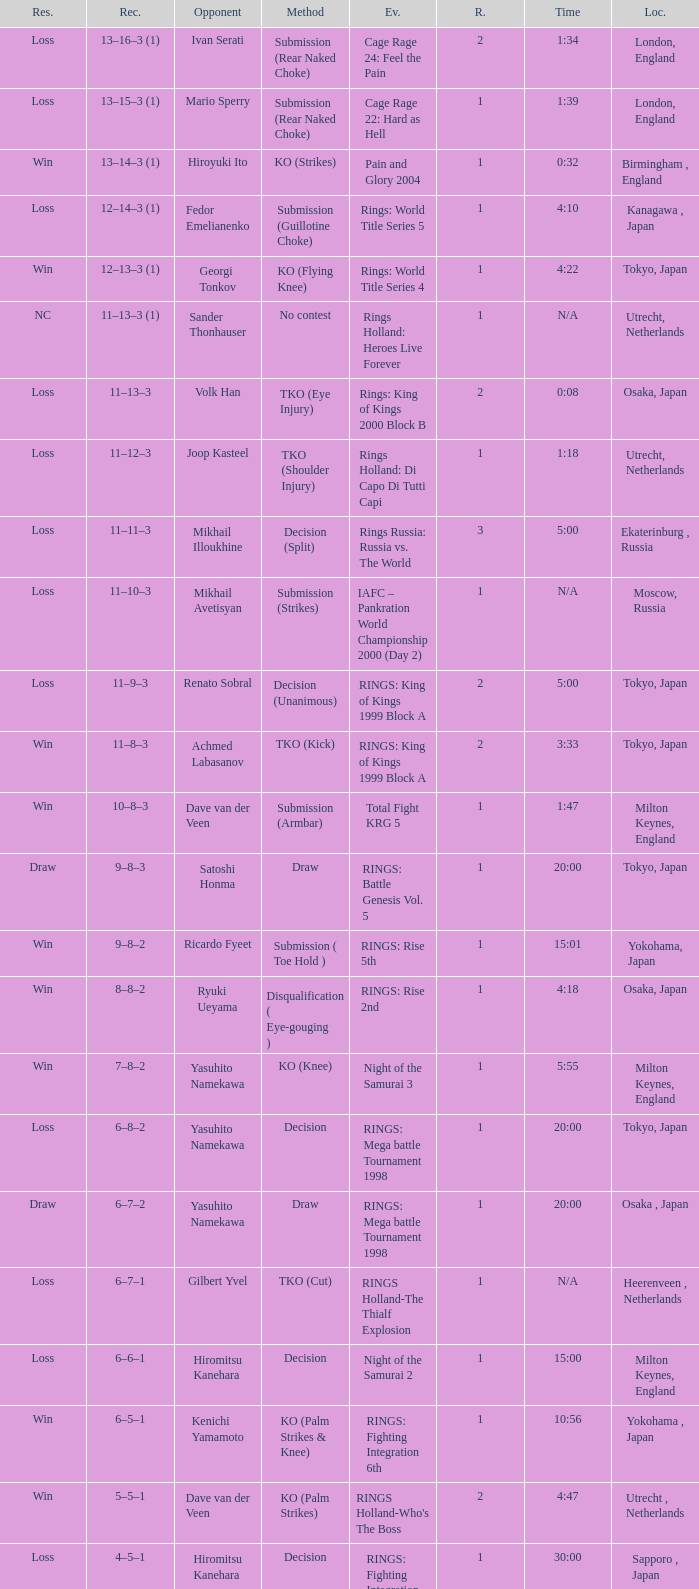What approach did the adversary of ivan serati take? Submission (Rear Naked Choke). Would you mind parsing the complete table? {'header': ['Res.', 'Rec.', 'Opponent', 'Method', 'Ev.', 'R.', 'Time', 'Loc.'], 'rows': [['Loss', '13–16–3 (1)', 'Ivan Serati', 'Submission (Rear Naked Choke)', 'Cage Rage 24: Feel the Pain', '2', '1:34', 'London, England'], ['Loss', '13–15–3 (1)', 'Mario Sperry', 'Submission (Rear Naked Choke)', 'Cage Rage 22: Hard as Hell', '1', '1:39', 'London, England'], ['Win', '13–14–3 (1)', 'Hiroyuki Ito', 'KO (Strikes)', 'Pain and Glory 2004', '1', '0:32', 'Birmingham , England'], ['Loss', '12–14–3 (1)', 'Fedor Emelianenko', 'Submission (Guillotine Choke)', 'Rings: World Title Series 5', '1', '4:10', 'Kanagawa , Japan'], ['Win', '12–13–3 (1)', 'Georgi Tonkov', 'KO (Flying Knee)', 'Rings: World Title Series 4', '1', '4:22', 'Tokyo, Japan'], ['NC', '11–13–3 (1)', 'Sander Thonhauser', 'No contest', 'Rings Holland: Heroes Live Forever', '1', 'N/A', 'Utrecht, Netherlands'], ['Loss', '11–13–3', 'Volk Han', 'TKO (Eye Injury)', 'Rings: King of Kings 2000 Block B', '2', '0:08', 'Osaka, Japan'], ['Loss', '11–12–3', 'Joop Kasteel', 'TKO (Shoulder Injury)', 'Rings Holland: Di Capo Di Tutti Capi', '1', '1:18', 'Utrecht, Netherlands'], ['Loss', '11–11–3', 'Mikhail Illoukhine', 'Decision (Split)', 'Rings Russia: Russia vs. The World', '3', '5:00', 'Ekaterinburg , Russia'], ['Loss', '11–10–3', 'Mikhail Avetisyan', 'Submission (Strikes)', 'IAFC – Pankration World Championship 2000 (Day 2)', '1', 'N/A', 'Moscow, Russia'], ['Loss', '11–9–3', 'Renato Sobral', 'Decision (Unanimous)', 'RINGS: King of Kings 1999 Block A', '2', '5:00', 'Tokyo, Japan'], ['Win', '11–8–3', 'Achmed Labasanov', 'TKO (Kick)', 'RINGS: King of Kings 1999 Block A', '2', '3:33', 'Tokyo, Japan'], ['Win', '10–8–3', 'Dave van der Veen', 'Submission (Armbar)', 'Total Fight KRG 5', '1', '1:47', 'Milton Keynes, England'], ['Draw', '9–8–3', 'Satoshi Honma', 'Draw', 'RINGS: Battle Genesis Vol. 5', '1', '20:00', 'Tokyo, Japan'], ['Win', '9–8–2', 'Ricardo Fyeet', 'Submission ( Toe Hold )', 'RINGS: Rise 5th', '1', '15:01', 'Yokohama, Japan'], ['Win', '8–8–2', 'Ryuki Ueyama', 'Disqualification ( Eye-gouging )', 'RINGS: Rise 2nd', '1', '4:18', 'Osaka, Japan'], ['Win', '7–8–2', 'Yasuhito Namekawa', 'KO (Knee)', 'Night of the Samurai 3', '1', '5:55', 'Milton Keynes, England'], ['Loss', '6–8–2', 'Yasuhito Namekawa', 'Decision', 'RINGS: Mega battle Tournament 1998', '1', '20:00', 'Tokyo, Japan'], ['Draw', '6–7–2', 'Yasuhito Namekawa', 'Draw', 'RINGS: Mega battle Tournament 1998', '1', '20:00', 'Osaka , Japan'], ['Loss', '6–7–1', 'Gilbert Yvel', 'TKO (Cut)', 'RINGS Holland-The Thialf Explosion', '1', 'N/A', 'Heerenveen , Netherlands'], ['Loss', '6–6–1', 'Hiromitsu Kanehara', 'Decision', 'Night of the Samurai 2', '1', '15:00', 'Milton Keynes, England'], ['Win', '6–5–1', 'Kenichi Yamamoto', 'KO (Palm Strikes & Knee)', 'RINGS: Fighting Integration 6th', '1', '10:56', 'Yokohama , Japan'], ['Win', '5–5–1', 'Dave van der Veen', 'KO (Palm Strikes)', "RINGS Holland-Who's The Boss", '2', '4:47', 'Utrecht , Netherlands'], ['Loss', '4–5–1', 'Hiromitsu Kanehara', 'Decision', 'RINGS: Fighting Integration 3rd', '1', '30:00', 'Sapporo , Japan'], ['Win', '4–4–1', 'Sander Thonhauser', 'Submission ( Armbar )', 'Night of the Samurai 1', '1', '0:55', 'Milton Keynes, England'], ['Loss', '3–4–1', 'Joop Kasteel', 'Submission ( Headlock )', 'RINGS: Mega Battle Tournament 1997', '1', '8:55', 'Tokyo, Japan'], ['Win', '3–3–1', 'Peter Dijkman', 'Submission ( Rear Naked Choke )', 'Total Fight Night', '1', '4:46', 'Milton Keynes, England'], ['Loss', '2–3–1', 'Masayuki Naruse', 'Submission ( Shoulder Necklock )', 'RINGS: Fighting Extension Vol. 4', '1', '12:58', 'Tokyo, Japan'], ['Win', '2–2–1', 'Sean McCully', 'Submission (Guillotine Choke)', 'RINGS: Battle Genesis Vol. 1', '1', '3:59', 'Tokyo, Japan'], ['Loss', '1–2–1', 'Hans Nijman', 'Submission ( Guillotine Choke )', 'RINGS Holland-The Final Challenge', '2', '0:51', 'Amsterdam, Netherlands'], ['Loss', '1–1–1', 'Cees Bezems', 'TKO (Cut)', 'IMA – Battle of Styles', '1', 'N/A', 'Amsterdam, Netherlands'], ['Draw', '1–0–1', 'Andre Mannaart', 'Draw', 'RINGS Holland-Kings of Martial Arts', '2', '5:00', 'Amsterdam , Netherlands'], ['Win', '1–0–0', 'Boston Jones', 'TKO (Cut)', 'Fighting Arts Gala', '2', '2:30', 'Milton Keynes , England']]} 